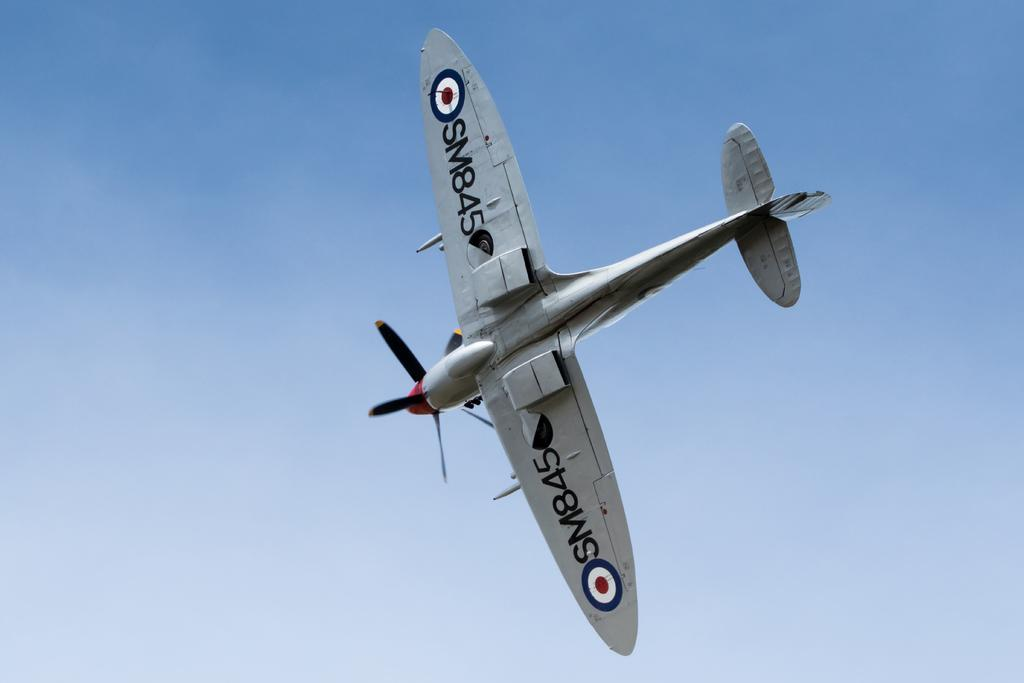<image>
Render a clear and concise summary of the photo. A single engine propellor plane banked to the right to reveal the SM845 number beneath its wings. 